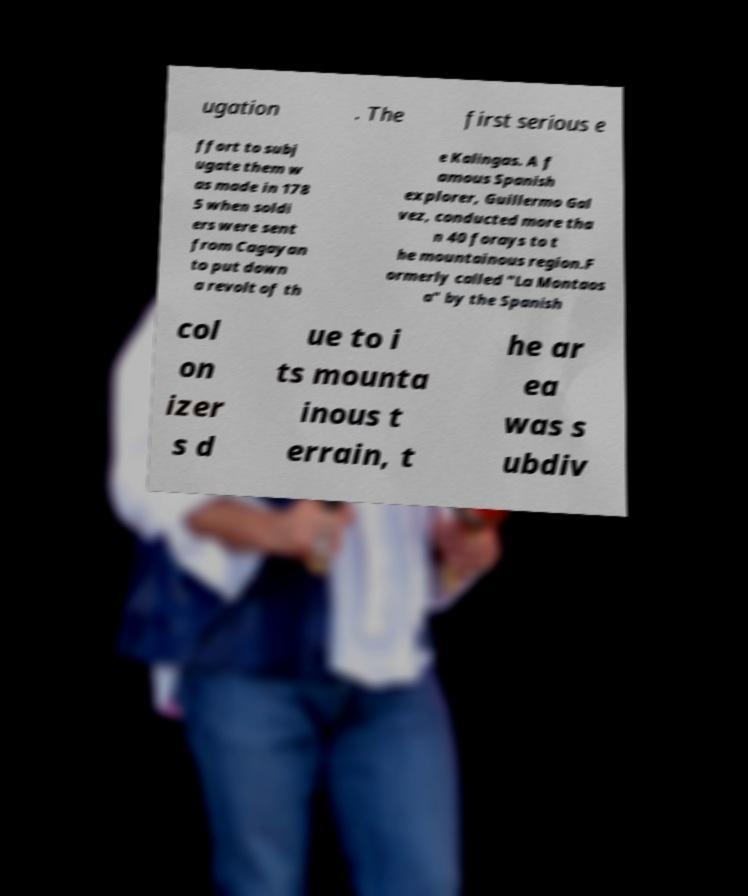Could you assist in decoding the text presented in this image and type it out clearly? ugation . The first serious e ffort to subj ugate them w as made in 178 5 when soldi ers were sent from Cagayan to put down a revolt of th e Kalingas. A f amous Spanish explorer, Guillermo Gal vez, conducted more tha n 40 forays to t he mountainous region.F ormerly called "La Montaos a" by the Spanish col on izer s d ue to i ts mounta inous t errain, t he ar ea was s ubdiv 